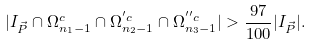<formula> <loc_0><loc_0><loc_500><loc_500>| I _ { \vec { P } } \cap \Omega ^ { c } _ { n _ { 1 } - 1 } \cap \Omega ^ { ^ { \prime } c } _ { n _ { 2 } - 1 } \cap \Omega ^ { ^ { \prime \prime } c } _ { n _ { 3 } - 1 } | > \frac { 9 7 } { 1 0 0 } | I _ { \vec { P } } | .</formula> 